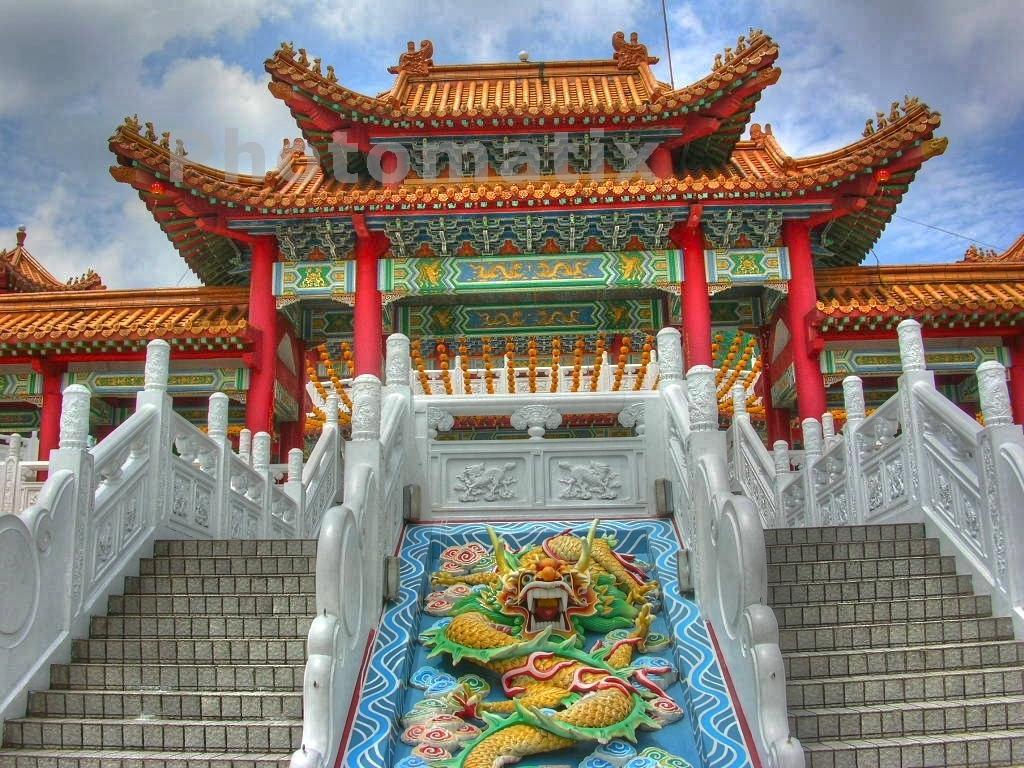Could you give a brief overview of what you see in this image? In this picture I can see building and I can see stairs and a blue cloudy sky and I can see watermark at the top of the picture. 